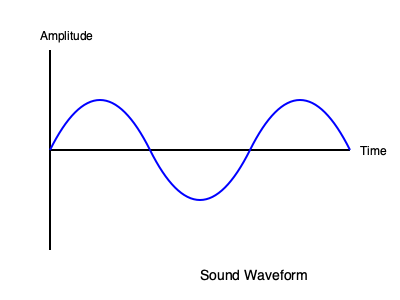In the sound waveform diagram above, how many complete cycles are shown? To determine the number of complete cycles in the waveform:

1. Understand what a cycle is: A cycle in a waveform is one complete repetition of the wave pattern.

2. Identify the wave pattern: In this diagram, we see a sinusoidal wave starting at the center line, going up, then down, and back to the center.

3. Count the cycles:
   - The wave starts at the center (y-axis).
   - It goes up to a peak, then down to a trough, and back to the center. This completes one full cycle.
   - We can see this pattern repeats two times completely.
   - The wave begins a third cycle but doesn't complete it.

4. Conclude: There are 2 complete cycles shown in the waveform.
Answer: 2 cycles 